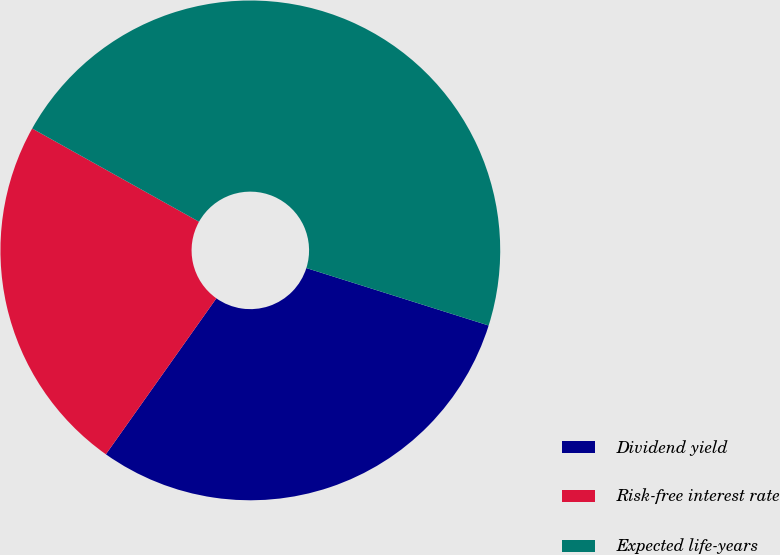Convert chart. <chart><loc_0><loc_0><loc_500><loc_500><pie_chart><fcel>Dividend yield<fcel>Risk-free interest rate<fcel>Expected life-years<nl><fcel>29.95%<fcel>23.3%<fcel>46.75%<nl></chart> 